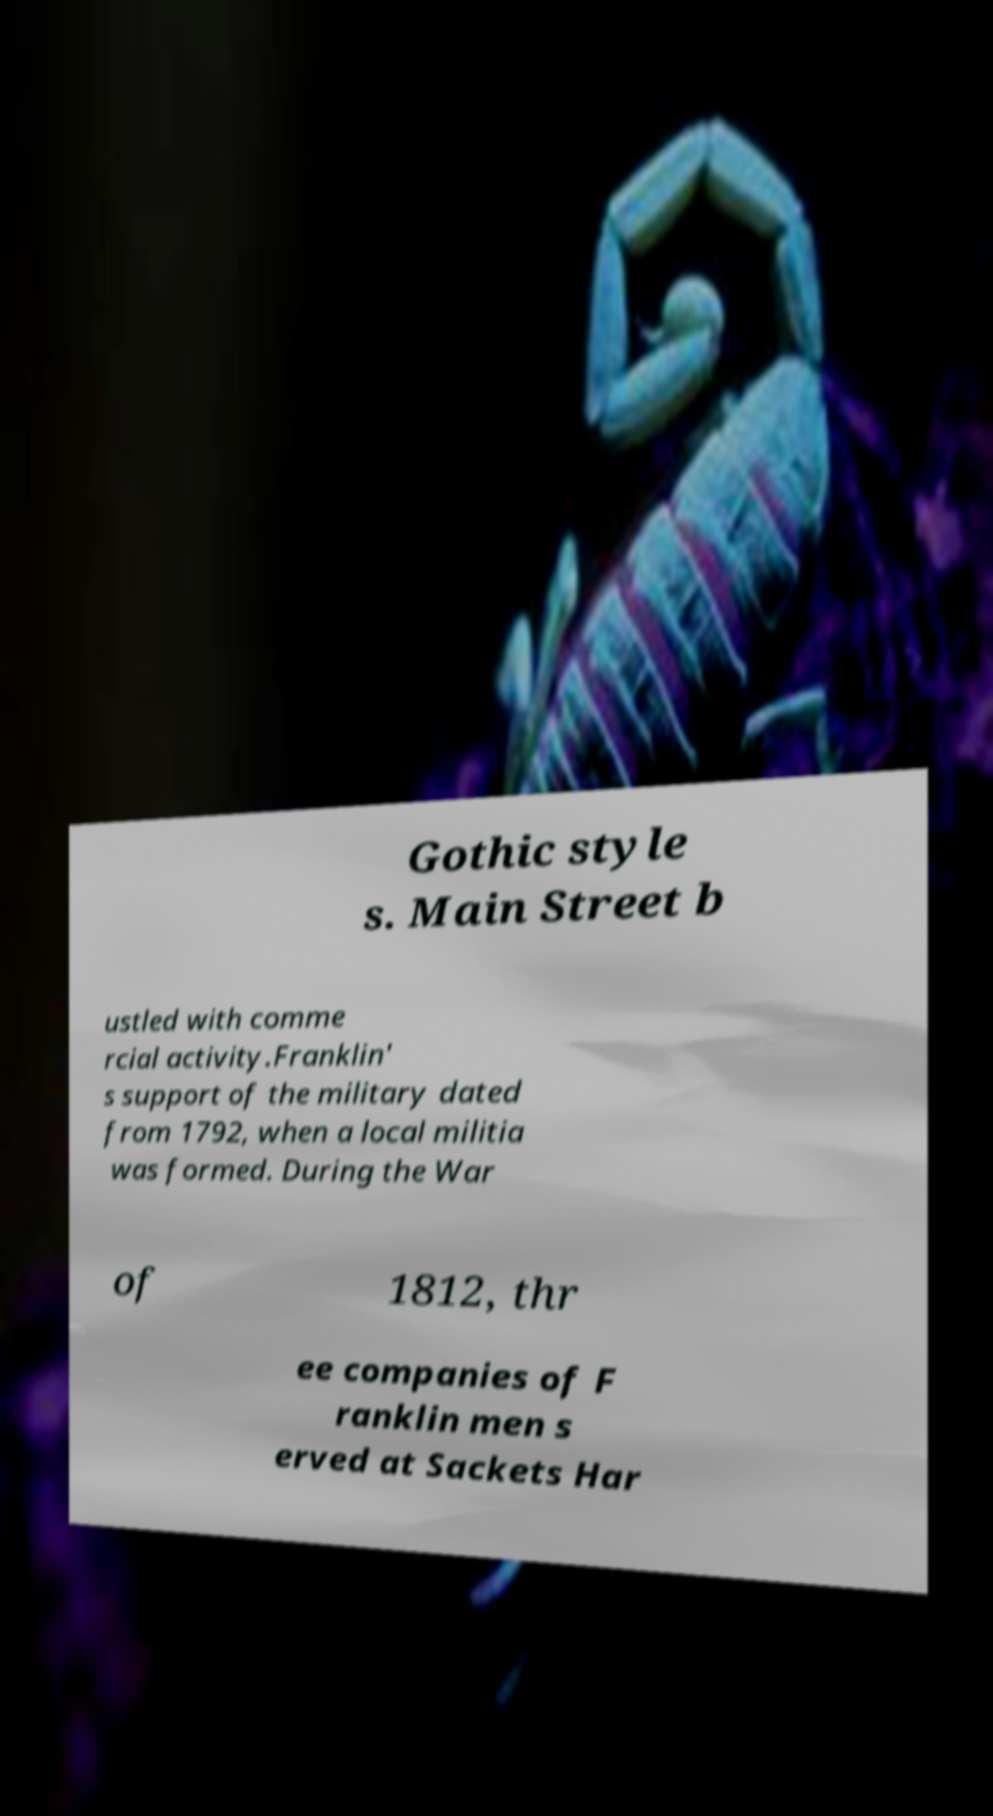Can you accurately transcribe the text from the provided image for me? Gothic style s. Main Street b ustled with comme rcial activity.Franklin' s support of the military dated from 1792, when a local militia was formed. During the War of 1812, thr ee companies of F ranklin men s erved at Sackets Har 